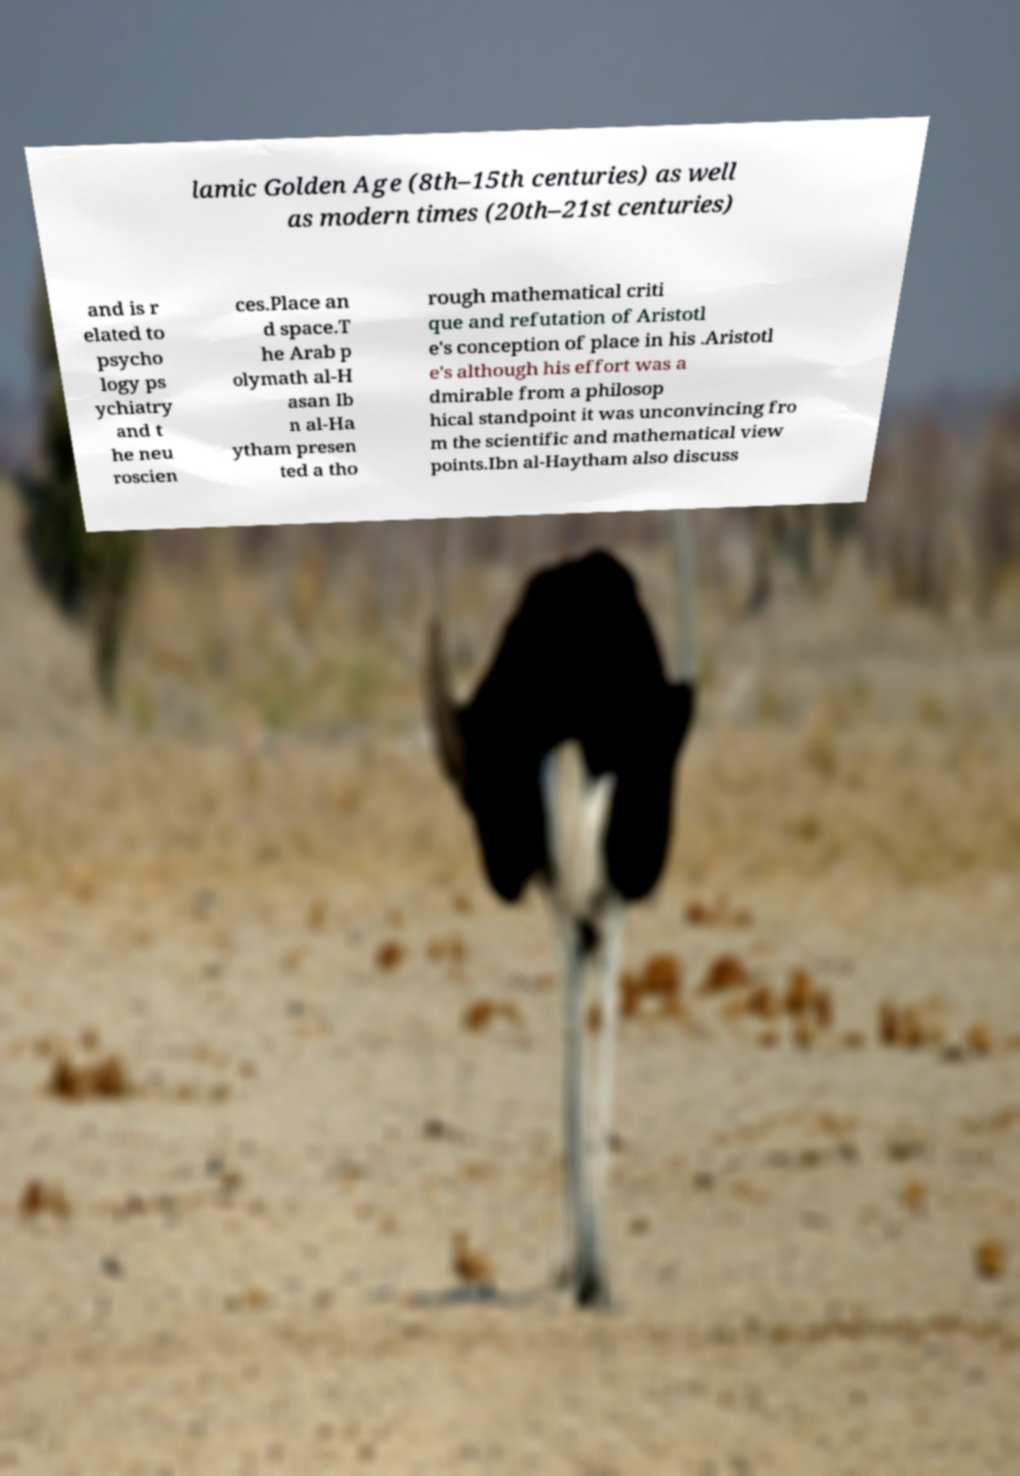Could you assist in decoding the text presented in this image and type it out clearly? lamic Golden Age (8th–15th centuries) as well as modern times (20th–21st centuries) and is r elated to psycho logy ps ychiatry and t he neu roscien ces.Place an d space.T he Arab p olymath al-H asan Ib n al-Ha ytham presen ted a tho rough mathematical criti que and refutation of Aristotl e's conception of place in his .Aristotl e's although his effort was a dmirable from a philosop hical standpoint it was unconvincing fro m the scientific and mathematical view points.Ibn al-Haytham also discuss 